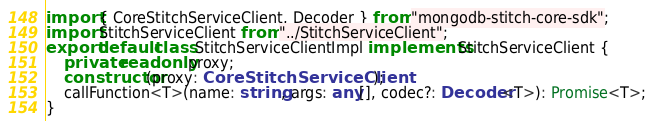Convert code to text. <code><loc_0><loc_0><loc_500><loc_500><_TypeScript_>import { CoreStitchServiceClient, Decoder } from "mongodb-stitch-core-sdk";
import StitchServiceClient from "../StitchServiceClient";
export default class StitchServiceClientImpl implements StitchServiceClient {
    private readonly proxy;
    constructor(proxy: CoreStitchServiceClient);
    callFunction<T>(name: string, args: any[], codec?: Decoder<T>): Promise<T>;
}
</code> 